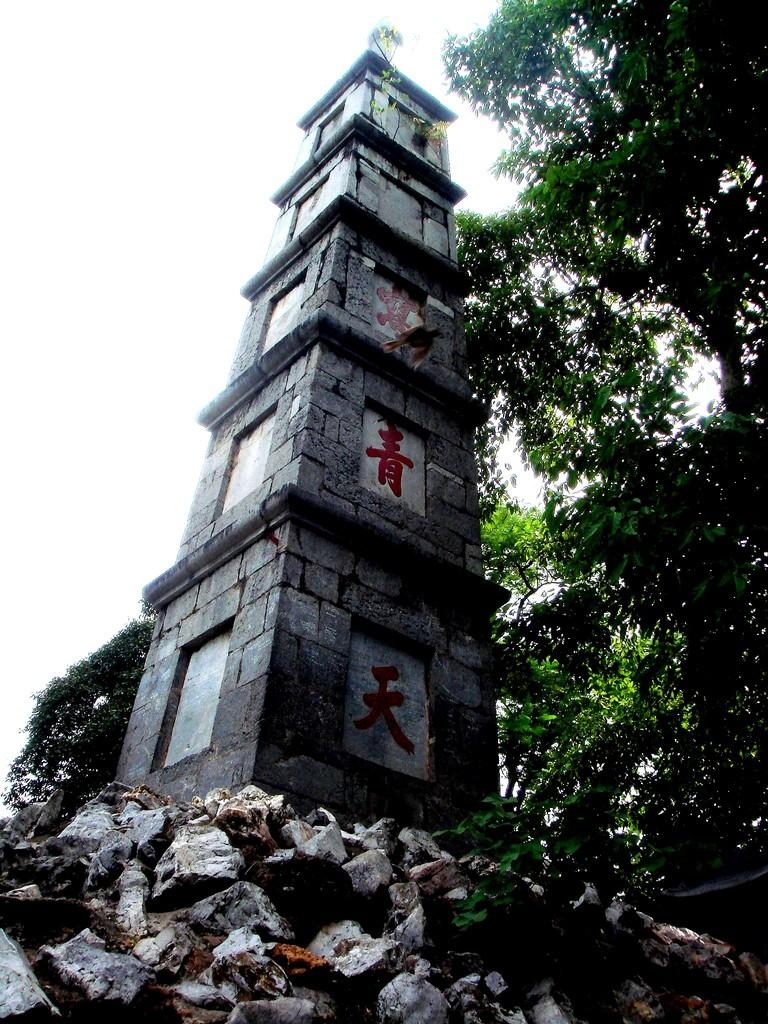What is the main structure in the image? A: There is a tower in the image. How is the tower positioned in relation to the ground? The tower is on rocks. What type of natural environment can be seen in the background of the image? There are trees in the background of the image. What is visible in the sky in the image? The sky is visible in the background of the image. What type of clam can be seen crawling on the rocks near the tower in the image? There is no clam present in the image; the tower is on rocks, but no clams are mentioned or visible. 